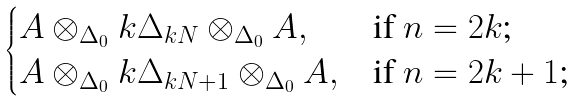Convert formula to latex. <formula><loc_0><loc_0><loc_500><loc_500>\begin{cases} A \otimes _ { \Delta _ { 0 } } { k } \Delta _ { k N } \otimes _ { \Delta _ { 0 } } A , & \text {if $n=2k$;} \\ A \otimes _ { \Delta _ { 0 } } { k } \Delta _ { k N + 1 } \otimes _ { \Delta _ { 0 } } A , & \text {if $n=2k+1$;} \end{cases}</formula> 